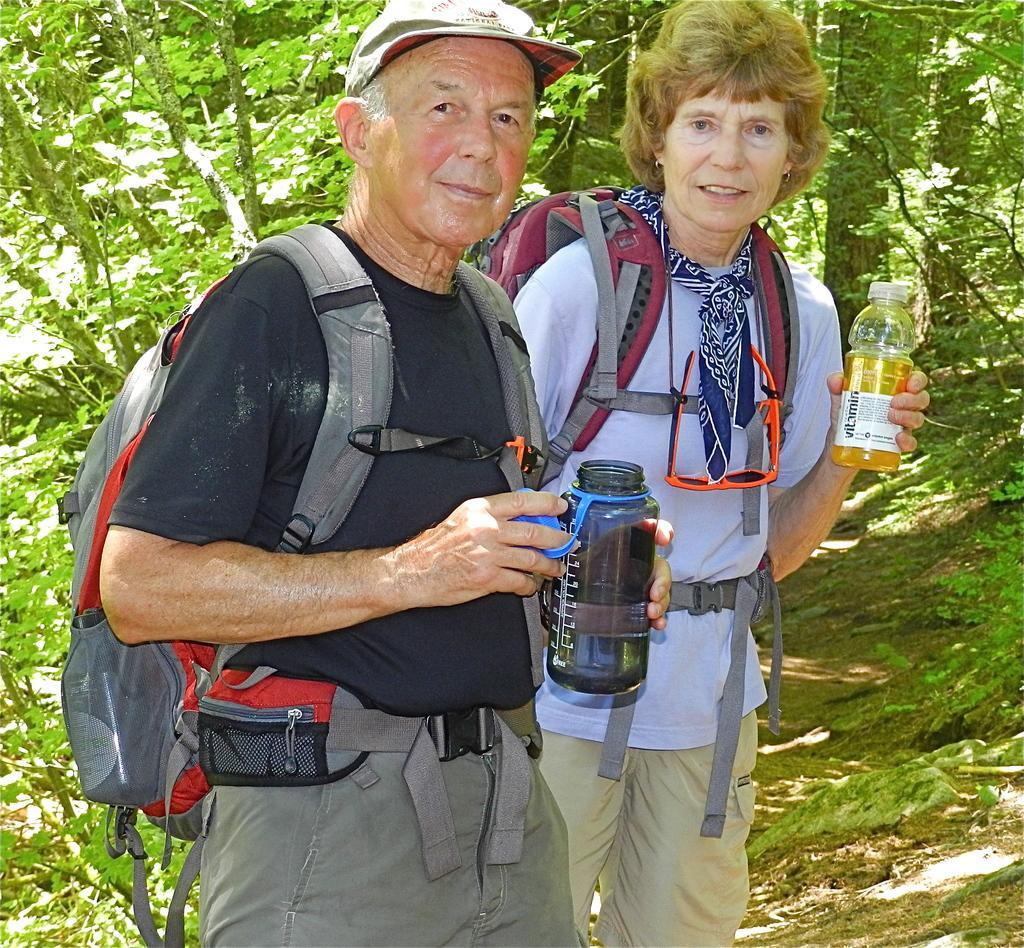Could you give a brief overview of what you see in this image? In this image i can a man and a woman wearing a bag and holding a bottle,at the back ground i can see a tree. 